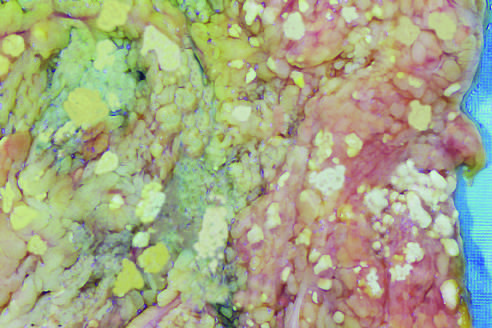how do the areas of white chalky deposits represent foci of fat necrosis?
Answer the question using a single word or phrase. With calcium soap formation (saponification) 